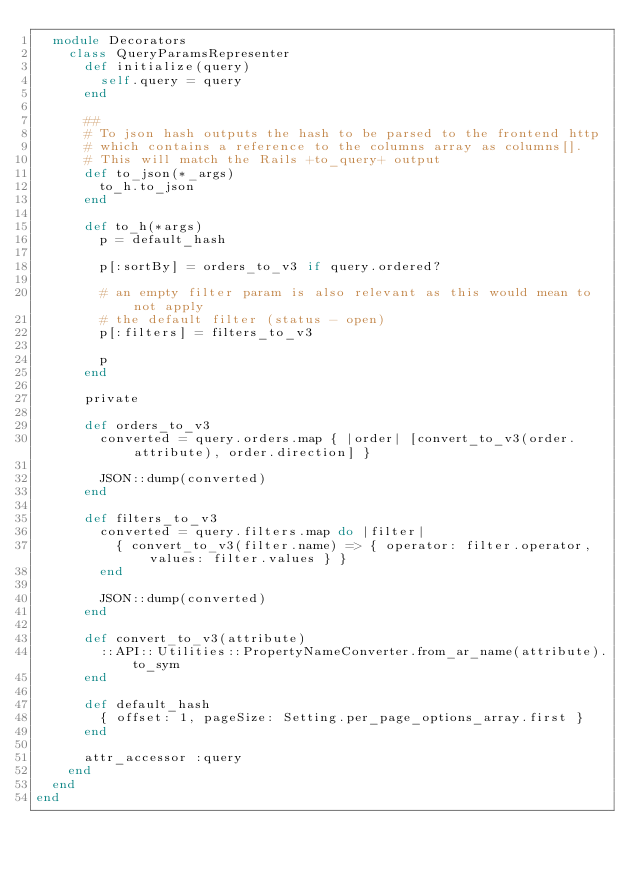Convert code to text. <code><loc_0><loc_0><loc_500><loc_500><_Ruby_>  module Decorators
    class QueryParamsRepresenter
      def initialize(query)
        self.query = query
      end

      ##
      # To json hash outputs the hash to be parsed to the frontend http
      # which contains a reference to the columns array as columns[].
      # This will match the Rails +to_query+ output
      def to_json(*_args)
        to_h.to_json
      end

      def to_h(*args)
        p = default_hash

        p[:sortBy] = orders_to_v3 if query.ordered?

        # an empty filter param is also relevant as this would mean to not apply
        # the default filter (status - open)
        p[:filters] = filters_to_v3

        p
      end

      private

      def orders_to_v3
        converted = query.orders.map { |order| [convert_to_v3(order.attribute), order.direction] }

        JSON::dump(converted)
      end

      def filters_to_v3
        converted = query.filters.map do |filter|
          { convert_to_v3(filter.name) => { operator: filter.operator, values: filter.values } }
        end

        JSON::dump(converted)
      end

      def convert_to_v3(attribute)
        ::API::Utilities::PropertyNameConverter.from_ar_name(attribute).to_sym
      end

      def default_hash
        { offset: 1, pageSize: Setting.per_page_options_array.first }
      end

      attr_accessor :query
    end
  end
end
</code> 